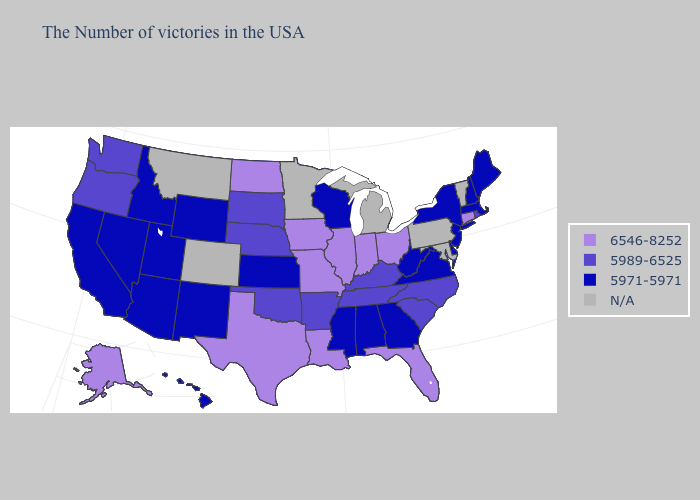Among the states that border Georgia , which have the highest value?
Concise answer only. Florida. Does the map have missing data?
Give a very brief answer. Yes. Which states have the highest value in the USA?
Write a very short answer. Connecticut, Ohio, Florida, Indiana, Illinois, Louisiana, Missouri, Iowa, Texas, North Dakota, Alaska. Name the states that have a value in the range 6546-8252?
Short answer required. Connecticut, Ohio, Florida, Indiana, Illinois, Louisiana, Missouri, Iowa, Texas, North Dakota, Alaska. Which states have the highest value in the USA?
Write a very short answer. Connecticut, Ohio, Florida, Indiana, Illinois, Louisiana, Missouri, Iowa, Texas, North Dakota, Alaska. Does the first symbol in the legend represent the smallest category?
Give a very brief answer. No. Does Kentucky have the lowest value in the USA?
Give a very brief answer. No. Which states hav the highest value in the MidWest?
Concise answer only. Ohio, Indiana, Illinois, Missouri, Iowa, North Dakota. What is the value of Indiana?
Write a very short answer. 6546-8252. Name the states that have a value in the range N/A?
Give a very brief answer. Vermont, Maryland, Pennsylvania, Michigan, Minnesota, Colorado, Montana. What is the highest value in the West ?
Short answer required. 6546-8252. Does North Carolina have the highest value in the USA?
Answer briefly. No. What is the lowest value in states that border Nebraska?
Answer briefly. 5971-5971. What is the value of Oregon?
Quick response, please. 5989-6525. Is the legend a continuous bar?
Short answer required. No. 